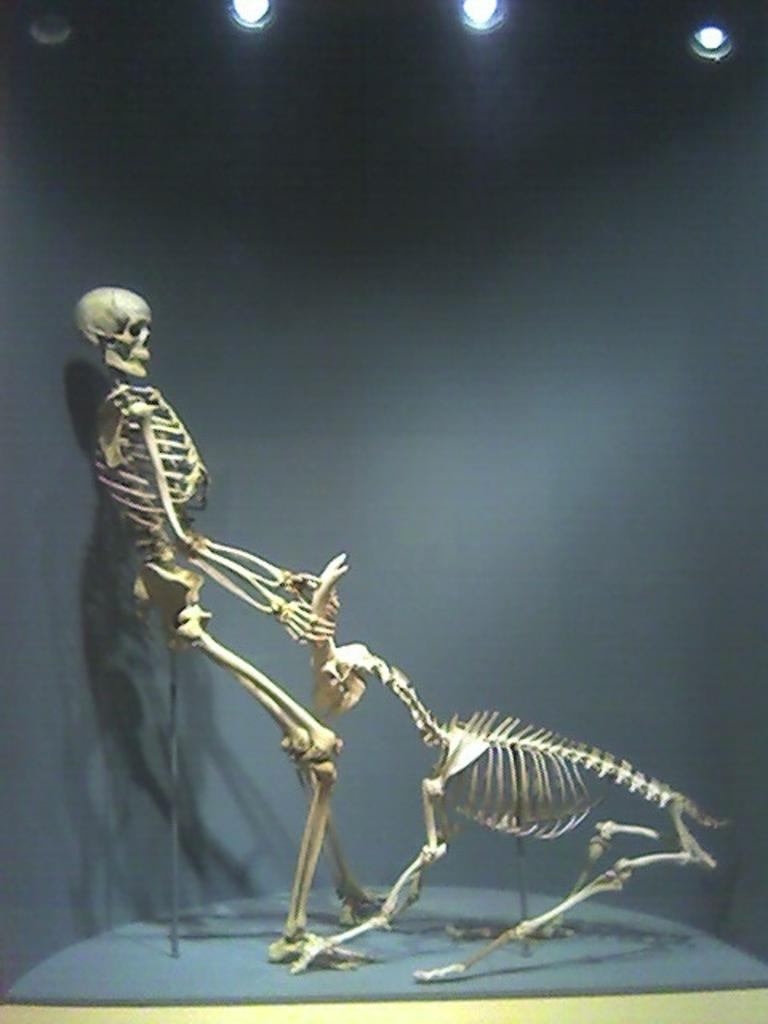What can be seen on the surface in the image? There are skeletons on the surface in the image. What is the background element in the image? There is a wall in the image. What can be used to illuminate the scene in the image? There are lights visible in the image. How many grapes are hanging from the wall in the image? There are no grapes present in the image; it features skeletons on the surface and a wall. Is there any grass visible in the image? There is no grass visible in the image. 